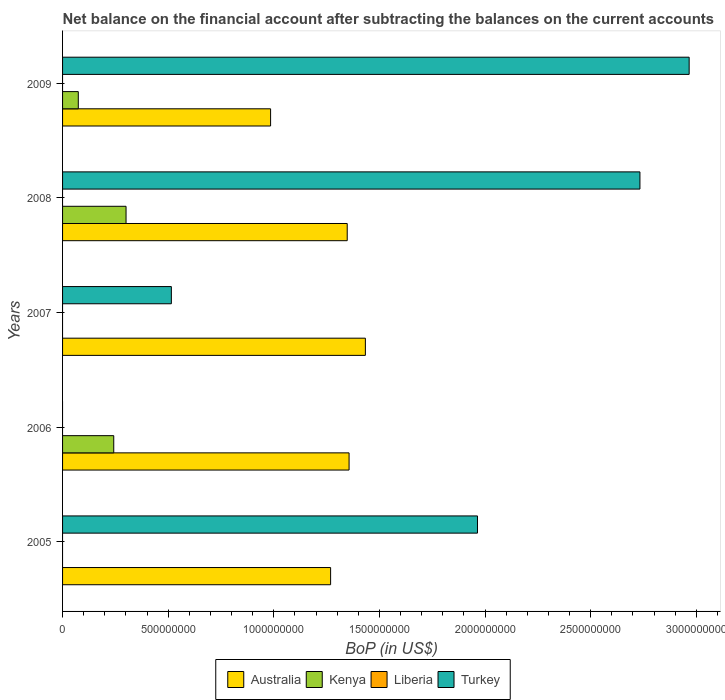How many different coloured bars are there?
Provide a short and direct response. 3. Are the number of bars on each tick of the Y-axis equal?
Give a very brief answer. No. How many bars are there on the 4th tick from the bottom?
Your response must be concise. 3. What is the label of the 3rd group of bars from the top?
Offer a terse response. 2007. In how many cases, is the number of bars for a given year not equal to the number of legend labels?
Keep it short and to the point. 5. Across all years, what is the maximum Balance of Payments in Australia?
Your answer should be compact. 1.43e+09. In which year was the Balance of Payments in Kenya maximum?
Provide a succinct answer. 2008. What is the total Balance of Payments in Australia in the graph?
Ensure brevity in your answer.  6.39e+09. What is the difference between the Balance of Payments in Australia in 2007 and that in 2008?
Provide a succinct answer. 8.59e+07. What is the difference between the Balance of Payments in Kenya in 2006 and the Balance of Payments in Turkey in 2009?
Provide a short and direct response. -2.72e+09. What is the average Balance of Payments in Australia per year?
Your response must be concise. 1.28e+09. In the year 2008, what is the difference between the Balance of Payments in Australia and Balance of Payments in Kenya?
Offer a terse response. 1.05e+09. In how many years, is the Balance of Payments in Kenya greater than 1400000000 US$?
Your response must be concise. 0. What is the ratio of the Balance of Payments in Australia in 2008 to that in 2009?
Provide a succinct answer. 1.37. Is the Balance of Payments in Australia in 2006 less than that in 2009?
Give a very brief answer. No. What is the difference between the highest and the second highest Balance of Payments in Kenya?
Make the answer very short. 5.82e+07. What is the difference between the highest and the lowest Balance of Payments in Turkey?
Offer a terse response. 2.97e+09. Is it the case that in every year, the sum of the Balance of Payments in Turkey and Balance of Payments in Kenya is greater than the sum of Balance of Payments in Liberia and Balance of Payments in Australia?
Give a very brief answer. No. Is it the case that in every year, the sum of the Balance of Payments in Turkey and Balance of Payments in Australia is greater than the Balance of Payments in Liberia?
Provide a short and direct response. Yes. Does the graph contain any zero values?
Your answer should be compact. Yes. What is the title of the graph?
Offer a very short reply. Net balance on the financial account after subtracting the balances on the current accounts. What is the label or title of the X-axis?
Provide a succinct answer. BoP (in US$). What is the label or title of the Y-axis?
Offer a terse response. Years. What is the BoP (in US$) of Australia in 2005?
Your response must be concise. 1.27e+09. What is the BoP (in US$) of Kenya in 2005?
Keep it short and to the point. 0. What is the BoP (in US$) of Turkey in 2005?
Offer a terse response. 1.96e+09. What is the BoP (in US$) of Australia in 2006?
Your answer should be compact. 1.36e+09. What is the BoP (in US$) in Kenya in 2006?
Provide a succinct answer. 2.42e+08. What is the BoP (in US$) in Australia in 2007?
Provide a succinct answer. 1.43e+09. What is the BoP (in US$) of Liberia in 2007?
Provide a succinct answer. 0. What is the BoP (in US$) of Turkey in 2007?
Your answer should be very brief. 5.15e+08. What is the BoP (in US$) of Australia in 2008?
Give a very brief answer. 1.35e+09. What is the BoP (in US$) in Kenya in 2008?
Keep it short and to the point. 3.01e+08. What is the BoP (in US$) of Liberia in 2008?
Your response must be concise. 0. What is the BoP (in US$) of Turkey in 2008?
Keep it short and to the point. 2.73e+09. What is the BoP (in US$) in Australia in 2009?
Offer a very short reply. 9.85e+08. What is the BoP (in US$) of Kenya in 2009?
Offer a terse response. 7.45e+07. What is the BoP (in US$) of Liberia in 2009?
Give a very brief answer. 0. What is the BoP (in US$) in Turkey in 2009?
Keep it short and to the point. 2.97e+09. Across all years, what is the maximum BoP (in US$) in Australia?
Offer a very short reply. 1.43e+09. Across all years, what is the maximum BoP (in US$) of Kenya?
Make the answer very short. 3.01e+08. Across all years, what is the maximum BoP (in US$) of Turkey?
Provide a succinct answer. 2.97e+09. Across all years, what is the minimum BoP (in US$) in Australia?
Your response must be concise. 9.85e+08. Across all years, what is the minimum BoP (in US$) of Kenya?
Make the answer very short. 0. What is the total BoP (in US$) of Australia in the graph?
Keep it short and to the point. 6.39e+09. What is the total BoP (in US$) of Kenya in the graph?
Your answer should be compact. 6.17e+08. What is the total BoP (in US$) in Turkey in the graph?
Ensure brevity in your answer.  8.18e+09. What is the difference between the BoP (in US$) in Australia in 2005 and that in 2006?
Offer a very short reply. -8.74e+07. What is the difference between the BoP (in US$) in Australia in 2005 and that in 2007?
Your answer should be compact. -1.65e+08. What is the difference between the BoP (in US$) of Turkey in 2005 and that in 2007?
Make the answer very short. 1.45e+09. What is the difference between the BoP (in US$) in Australia in 2005 and that in 2008?
Give a very brief answer. -7.86e+07. What is the difference between the BoP (in US$) of Turkey in 2005 and that in 2008?
Offer a very short reply. -7.69e+08. What is the difference between the BoP (in US$) in Australia in 2005 and that in 2009?
Your answer should be compact. 2.84e+08. What is the difference between the BoP (in US$) of Turkey in 2005 and that in 2009?
Keep it short and to the point. -1.00e+09. What is the difference between the BoP (in US$) in Australia in 2006 and that in 2007?
Your response must be concise. -7.72e+07. What is the difference between the BoP (in US$) of Australia in 2006 and that in 2008?
Provide a short and direct response. 8.75e+06. What is the difference between the BoP (in US$) of Kenya in 2006 and that in 2008?
Offer a terse response. -5.82e+07. What is the difference between the BoP (in US$) of Australia in 2006 and that in 2009?
Offer a very short reply. 3.72e+08. What is the difference between the BoP (in US$) of Kenya in 2006 and that in 2009?
Your response must be concise. 1.68e+08. What is the difference between the BoP (in US$) of Australia in 2007 and that in 2008?
Offer a very short reply. 8.59e+07. What is the difference between the BoP (in US$) of Turkey in 2007 and that in 2008?
Your response must be concise. -2.22e+09. What is the difference between the BoP (in US$) of Australia in 2007 and that in 2009?
Make the answer very short. 4.49e+08. What is the difference between the BoP (in US$) of Turkey in 2007 and that in 2009?
Ensure brevity in your answer.  -2.45e+09. What is the difference between the BoP (in US$) in Australia in 2008 and that in 2009?
Provide a short and direct response. 3.63e+08. What is the difference between the BoP (in US$) in Kenya in 2008 and that in 2009?
Give a very brief answer. 2.26e+08. What is the difference between the BoP (in US$) of Turkey in 2008 and that in 2009?
Offer a very short reply. -2.33e+08. What is the difference between the BoP (in US$) in Australia in 2005 and the BoP (in US$) in Kenya in 2006?
Your answer should be compact. 1.03e+09. What is the difference between the BoP (in US$) of Australia in 2005 and the BoP (in US$) of Turkey in 2007?
Keep it short and to the point. 7.54e+08. What is the difference between the BoP (in US$) in Australia in 2005 and the BoP (in US$) in Kenya in 2008?
Give a very brief answer. 9.68e+08. What is the difference between the BoP (in US$) of Australia in 2005 and the BoP (in US$) of Turkey in 2008?
Provide a short and direct response. -1.46e+09. What is the difference between the BoP (in US$) in Australia in 2005 and the BoP (in US$) in Kenya in 2009?
Offer a very short reply. 1.19e+09. What is the difference between the BoP (in US$) of Australia in 2005 and the BoP (in US$) of Turkey in 2009?
Your response must be concise. -1.70e+09. What is the difference between the BoP (in US$) in Australia in 2006 and the BoP (in US$) in Turkey in 2007?
Your answer should be very brief. 8.41e+08. What is the difference between the BoP (in US$) of Kenya in 2006 and the BoP (in US$) of Turkey in 2007?
Make the answer very short. -2.73e+08. What is the difference between the BoP (in US$) in Australia in 2006 and the BoP (in US$) in Kenya in 2008?
Offer a terse response. 1.06e+09. What is the difference between the BoP (in US$) in Australia in 2006 and the BoP (in US$) in Turkey in 2008?
Keep it short and to the point. -1.38e+09. What is the difference between the BoP (in US$) in Kenya in 2006 and the BoP (in US$) in Turkey in 2008?
Offer a very short reply. -2.49e+09. What is the difference between the BoP (in US$) of Australia in 2006 and the BoP (in US$) of Kenya in 2009?
Offer a terse response. 1.28e+09. What is the difference between the BoP (in US$) in Australia in 2006 and the BoP (in US$) in Turkey in 2009?
Ensure brevity in your answer.  -1.61e+09. What is the difference between the BoP (in US$) in Kenya in 2006 and the BoP (in US$) in Turkey in 2009?
Offer a terse response. -2.72e+09. What is the difference between the BoP (in US$) of Australia in 2007 and the BoP (in US$) of Kenya in 2008?
Ensure brevity in your answer.  1.13e+09. What is the difference between the BoP (in US$) in Australia in 2007 and the BoP (in US$) in Turkey in 2008?
Keep it short and to the point. -1.30e+09. What is the difference between the BoP (in US$) of Australia in 2007 and the BoP (in US$) of Kenya in 2009?
Ensure brevity in your answer.  1.36e+09. What is the difference between the BoP (in US$) in Australia in 2007 and the BoP (in US$) in Turkey in 2009?
Your answer should be compact. -1.53e+09. What is the difference between the BoP (in US$) in Australia in 2008 and the BoP (in US$) in Kenya in 2009?
Your response must be concise. 1.27e+09. What is the difference between the BoP (in US$) in Australia in 2008 and the BoP (in US$) in Turkey in 2009?
Your answer should be compact. -1.62e+09. What is the difference between the BoP (in US$) in Kenya in 2008 and the BoP (in US$) in Turkey in 2009?
Your response must be concise. -2.67e+09. What is the average BoP (in US$) of Australia per year?
Offer a very short reply. 1.28e+09. What is the average BoP (in US$) of Kenya per year?
Your answer should be very brief. 1.23e+08. What is the average BoP (in US$) in Turkey per year?
Your response must be concise. 1.64e+09. In the year 2005, what is the difference between the BoP (in US$) of Australia and BoP (in US$) of Turkey?
Your answer should be compact. -6.95e+08. In the year 2006, what is the difference between the BoP (in US$) in Australia and BoP (in US$) in Kenya?
Make the answer very short. 1.11e+09. In the year 2007, what is the difference between the BoP (in US$) of Australia and BoP (in US$) of Turkey?
Ensure brevity in your answer.  9.18e+08. In the year 2008, what is the difference between the BoP (in US$) of Australia and BoP (in US$) of Kenya?
Offer a very short reply. 1.05e+09. In the year 2008, what is the difference between the BoP (in US$) in Australia and BoP (in US$) in Turkey?
Ensure brevity in your answer.  -1.39e+09. In the year 2008, what is the difference between the BoP (in US$) in Kenya and BoP (in US$) in Turkey?
Offer a terse response. -2.43e+09. In the year 2009, what is the difference between the BoP (in US$) in Australia and BoP (in US$) in Kenya?
Give a very brief answer. 9.10e+08. In the year 2009, what is the difference between the BoP (in US$) in Australia and BoP (in US$) in Turkey?
Provide a succinct answer. -1.98e+09. In the year 2009, what is the difference between the BoP (in US$) of Kenya and BoP (in US$) of Turkey?
Your answer should be compact. -2.89e+09. What is the ratio of the BoP (in US$) of Australia in 2005 to that in 2006?
Give a very brief answer. 0.94. What is the ratio of the BoP (in US$) of Australia in 2005 to that in 2007?
Your answer should be compact. 0.89. What is the ratio of the BoP (in US$) in Turkey in 2005 to that in 2007?
Offer a terse response. 3.81. What is the ratio of the BoP (in US$) in Australia in 2005 to that in 2008?
Make the answer very short. 0.94. What is the ratio of the BoP (in US$) of Turkey in 2005 to that in 2008?
Your response must be concise. 0.72. What is the ratio of the BoP (in US$) in Australia in 2005 to that in 2009?
Provide a succinct answer. 1.29. What is the ratio of the BoP (in US$) in Turkey in 2005 to that in 2009?
Ensure brevity in your answer.  0.66. What is the ratio of the BoP (in US$) in Australia in 2006 to that in 2007?
Offer a very short reply. 0.95. What is the ratio of the BoP (in US$) in Kenya in 2006 to that in 2008?
Ensure brevity in your answer.  0.81. What is the ratio of the BoP (in US$) of Australia in 2006 to that in 2009?
Offer a terse response. 1.38. What is the ratio of the BoP (in US$) in Kenya in 2006 to that in 2009?
Ensure brevity in your answer.  3.25. What is the ratio of the BoP (in US$) of Australia in 2007 to that in 2008?
Ensure brevity in your answer.  1.06. What is the ratio of the BoP (in US$) in Turkey in 2007 to that in 2008?
Give a very brief answer. 0.19. What is the ratio of the BoP (in US$) of Australia in 2007 to that in 2009?
Your answer should be compact. 1.46. What is the ratio of the BoP (in US$) in Turkey in 2007 to that in 2009?
Give a very brief answer. 0.17. What is the ratio of the BoP (in US$) in Australia in 2008 to that in 2009?
Offer a very short reply. 1.37. What is the ratio of the BoP (in US$) in Kenya in 2008 to that in 2009?
Your answer should be very brief. 4.04. What is the ratio of the BoP (in US$) in Turkey in 2008 to that in 2009?
Provide a succinct answer. 0.92. What is the difference between the highest and the second highest BoP (in US$) in Australia?
Keep it short and to the point. 7.72e+07. What is the difference between the highest and the second highest BoP (in US$) of Kenya?
Offer a very short reply. 5.82e+07. What is the difference between the highest and the second highest BoP (in US$) in Turkey?
Your answer should be compact. 2.33e+08. What is the difference between the highest and the lowest BoP (in US$) of Australia?
Your response must be concise. 4.49e+08. What is the difference between the highest and the lowest BoP (in US$) of Kenya?
Offer a terse response. 3.01e+08. What is the difference between the highest and the lowest BoP (in US$) of Turkey?
Ensure brevity in your answer.  2.97e+09. 